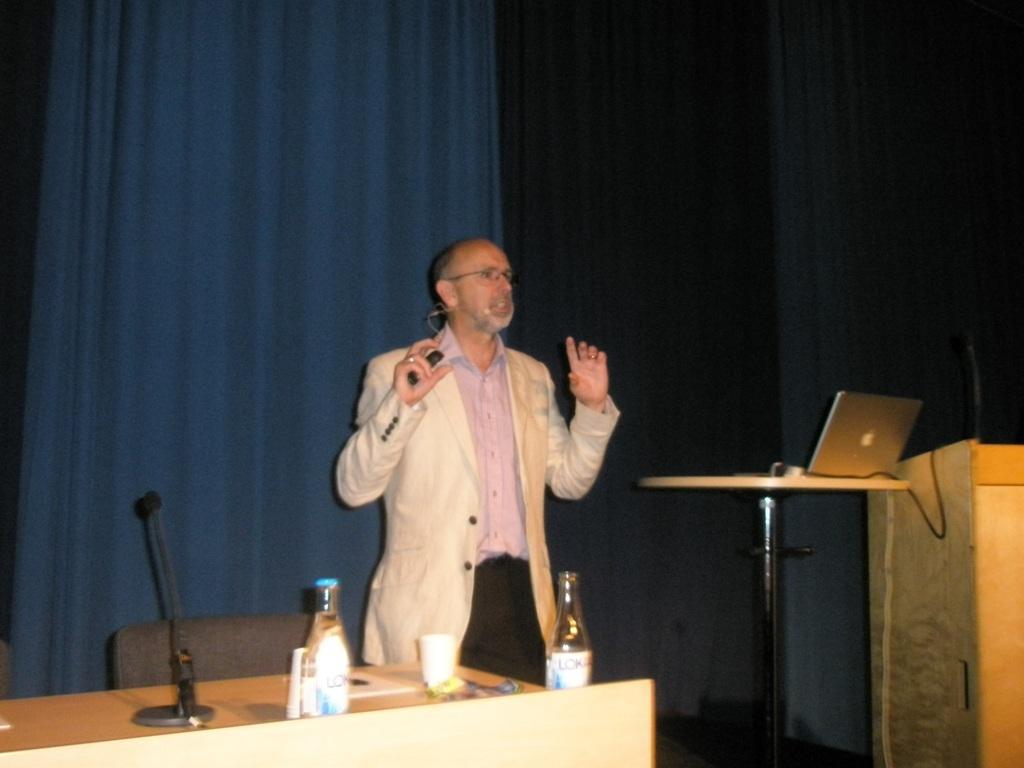Describe this image in one or two sentences. In this image i can see a man wearing a pink shirt, black pant and jacket standing and holding a object in his hand. I can see a desk on which there are few water bottles, few cups and a microphone. In the background i can see a curtain, a laptop and a podium. 